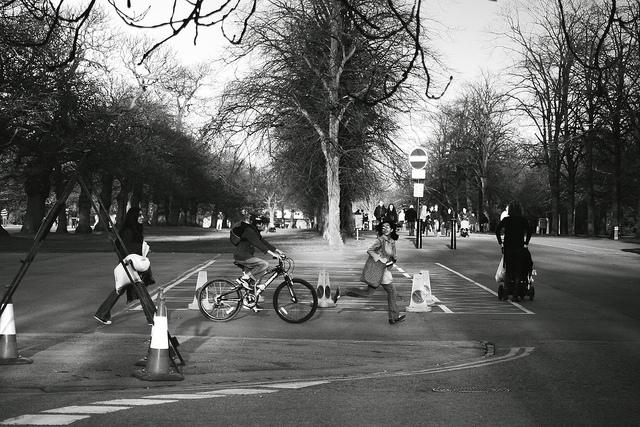Is there somebody on a bicycle?
Give a very brief answer. Yes. What are the people doing?
Answer briefly. Moving. Are there cones?
Answer briefly. Yes. 